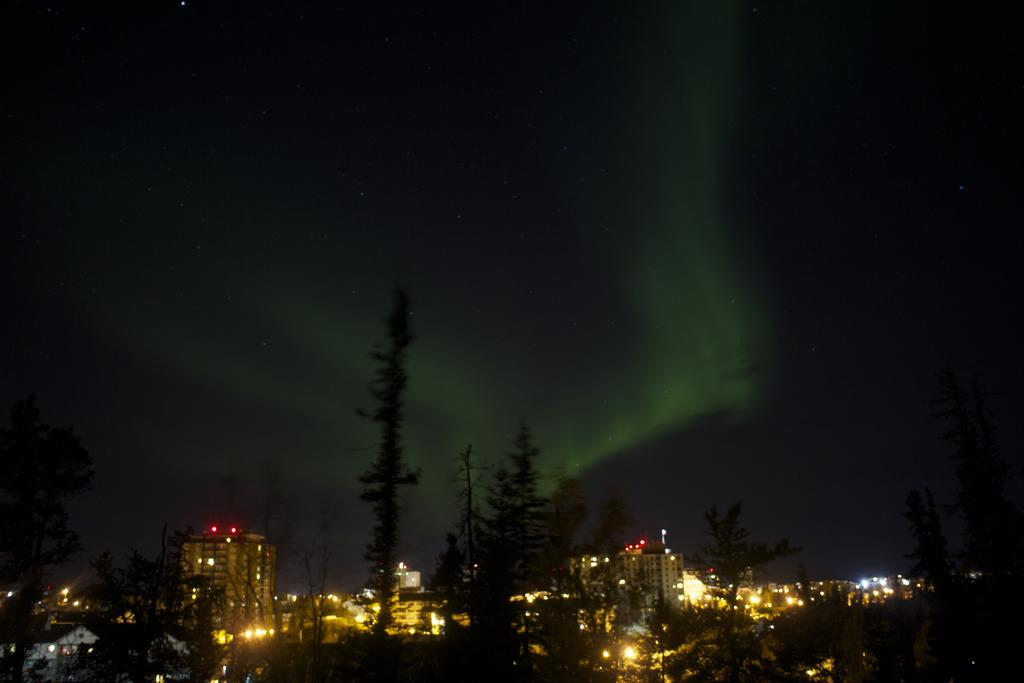What type of natural elements can be seen in the image? There are many trees in the image. What type of man-made structures are visible in the background of the image? There are buildings with lights in the background of the image. What part of the natural environment is visible in the image? The sky is visible in the background of the image. What type of tools does the carpenter use in the image? There is no carpenter present in the image, so it is not possible to determine what tools they might use. What flavor of butter is spread on the trees in the image? There is no butter present in the image, and trees do not require butter for any purpose. 